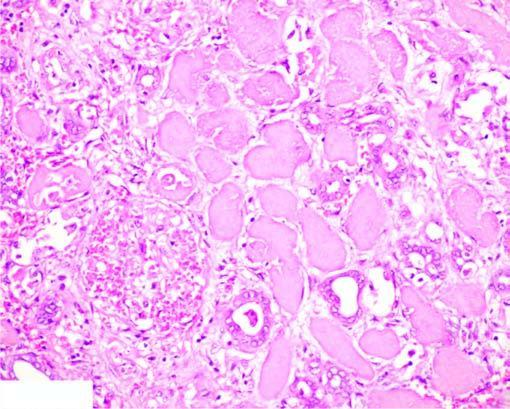do the tubular epithelial cells show granular debris?
Answer the question using a single word or phrase. No 